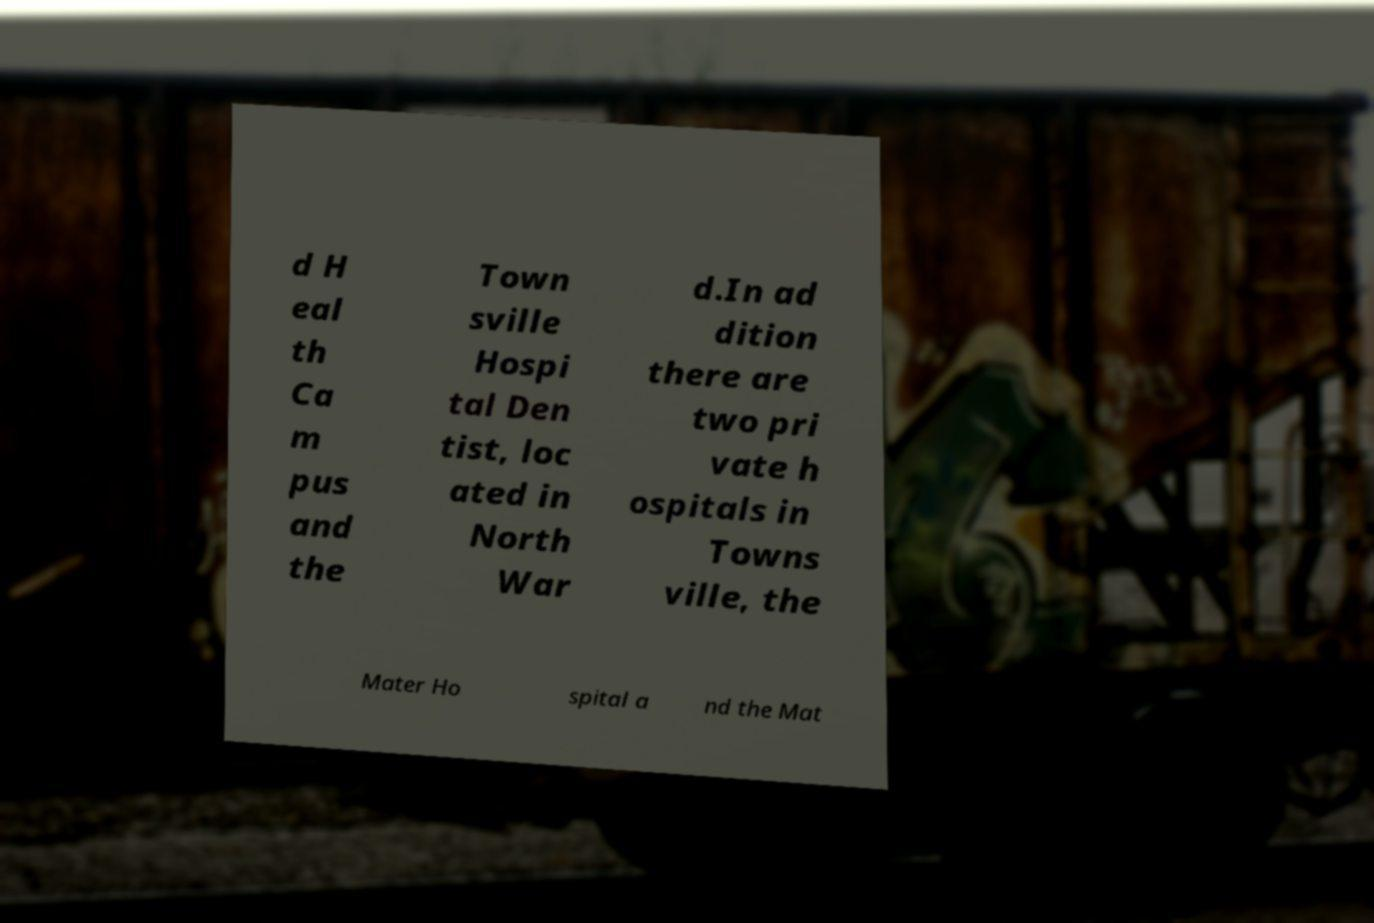I need the written content from this picture converted into text. Can you do that? d H eal th Ca m pus and the Town sville Hospi tal Den tist, loc ated in North War d.In ad dition there are two pri vate h ospitals in Towns ville, the Mater Ho spital a nd the Mat 